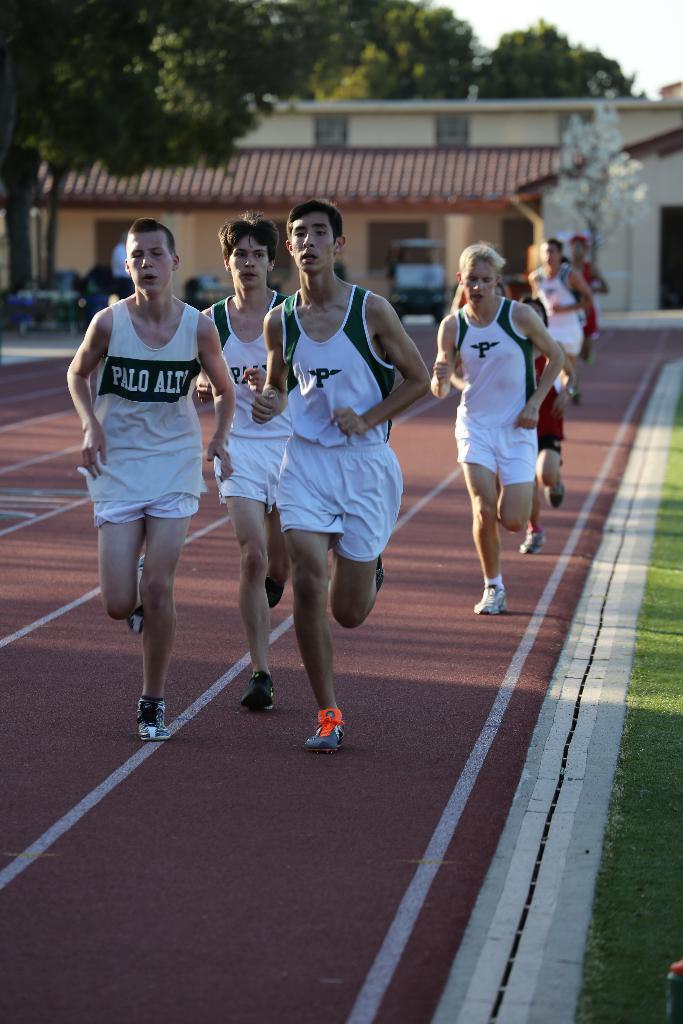In one or two sentences, can you explain what this image depicts? In this image, we can see persons wearing clothes and running on the track. There is a building and some trees at the top of the image. 